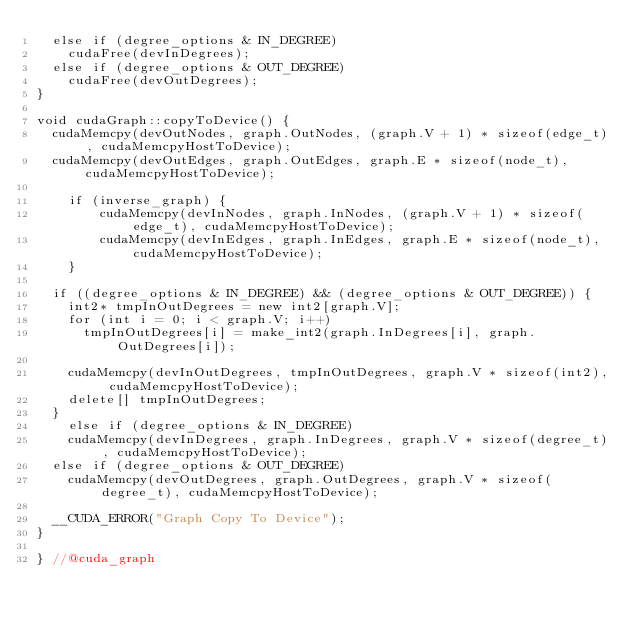<code> <loc_0><loc_0><loc_500><loc_500><_Cuda_>	else if (degree_options & IN_DEGREE)
		cudaFree(devInDegrees);
	else if (degree_options & OUT_DEGREE)
		cudaFree(devOutDegrees);
}

void cudaGraph::copyToDevice() {
	cudaMemcpy(devOutNodes, graph.OutNodes, (graph.V + 1) * sizeof(edge_t), cudaMemcpyHostToDevice);
	cudaMemcpy(devOutEdges, graph.OutEdges, graph.E * sizeof(node_t), cudaMemcpyHostToDevice);

    if (inverse_graph) {
        cudaMemcpy(devInNodes, graph.InNodes, (graph.V + 1) * sizeof(edge_t), cudaMemcpyHostToDevice);
        cudaMemcpy(devInEdges, graph.InEdges, graph.E * sizeof(node_t), cudaMemcpyHostToDevice);
    }

	if ((degree_options & IN_DEGREE) && (degree_options & OUT_DEGREE)) {
		int2* tmpInOutDegrees = new int2[graph.V];
		for (int i = 0; i < graph.V; i++)
			tmpInOutDegrees[i] = make_int2(graph.InDegrees[i], graph.OutDegrees[i]);

		cudaMemcpy(devInOutDegrees, tmpInOutDegrees, graph.V * sizeof(int2), cudaMemcpyHostToDevice);
		delete[] tmpInOutDegrees;
	}
    else if (degree_options & IN_DEGREE)
		cudaMemcpy(devInDegrees, graph.InDegrees, graph.V * sizeof(degree_t), cudaMemcpyHostToDevice);
	else if (degree_options & OUT_DEGREE)
		cudaMemcpy(devOutDegrees, graph.OutDegrees, graph.V * sizeof(degree_t), cudaMemcpyHostToDevice);

	__CUDA_ERROR("Graph Copy To Device");
}

} //@cuda_graph
</code> 